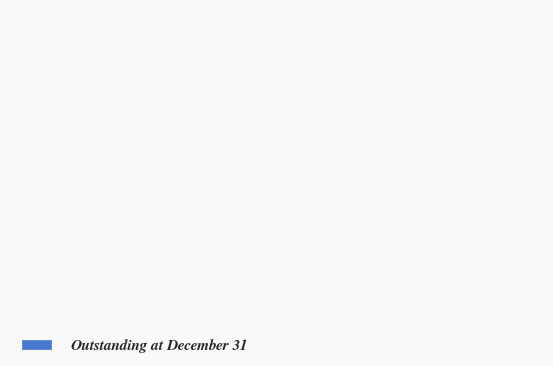<chart> <loc_0><loc_0><loc_500><loc_500><pie_chart><fcel>Outstanding at December 31<nl><fcel>100.0%<nl></chart> 